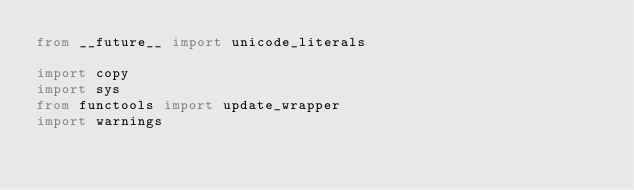<code> <loc_0><loc_0><loc_500><loc_500><_Python_>from __future__ import unicode_literals

import copy
import sys
from functools import update_wrapper
import warnings
</code> 